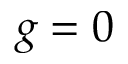Convert formula to latex. <formula><loc_0><loc_0><loc_500><loc_500>g = 0</formula> 